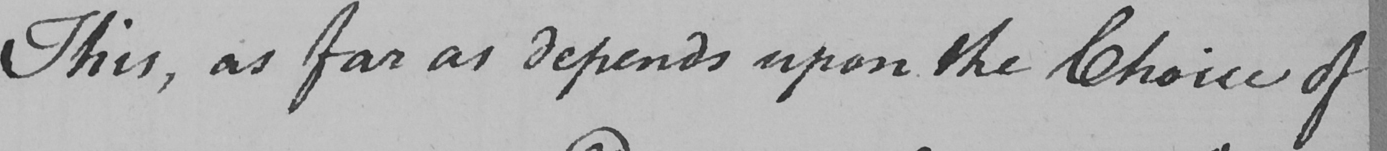Can you tell me what this handwritten text says? This , as far as depends upon the Choice of 